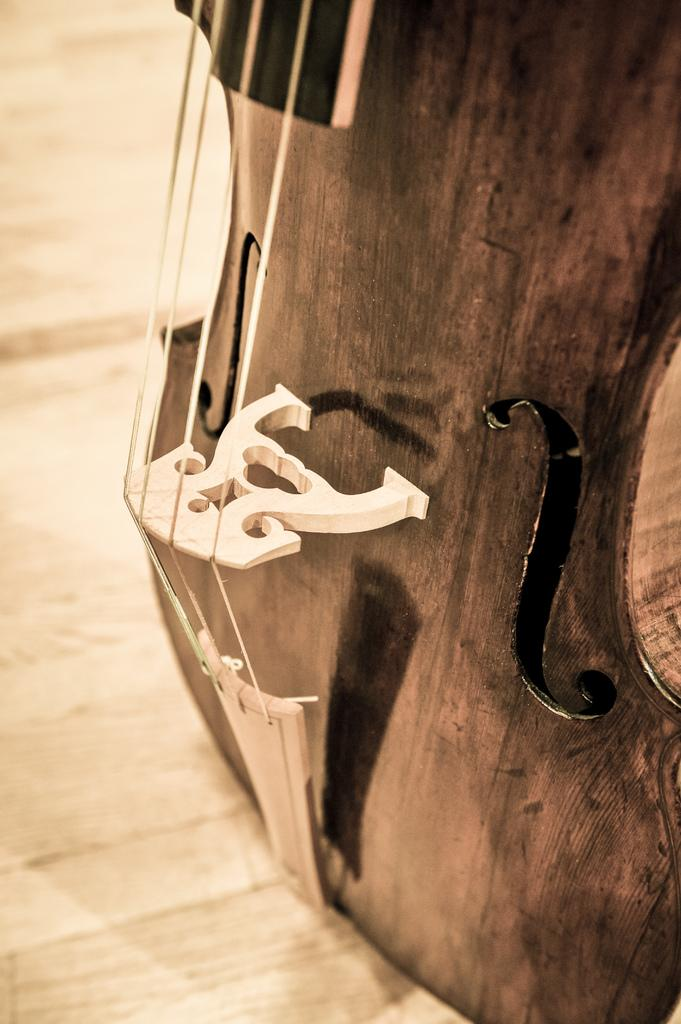What musical instrument is partially visible in the image? There is a part of a guitar in the image. What are the guitar's strings used for? The guitar's strings are used for playing music. On what surface is the guitar placed? The guitar is placed on a wooden surface. Where is the stove located in the image? There is no stove present in the image. What type of alley is visible in the image? There is no alley present in the image. 